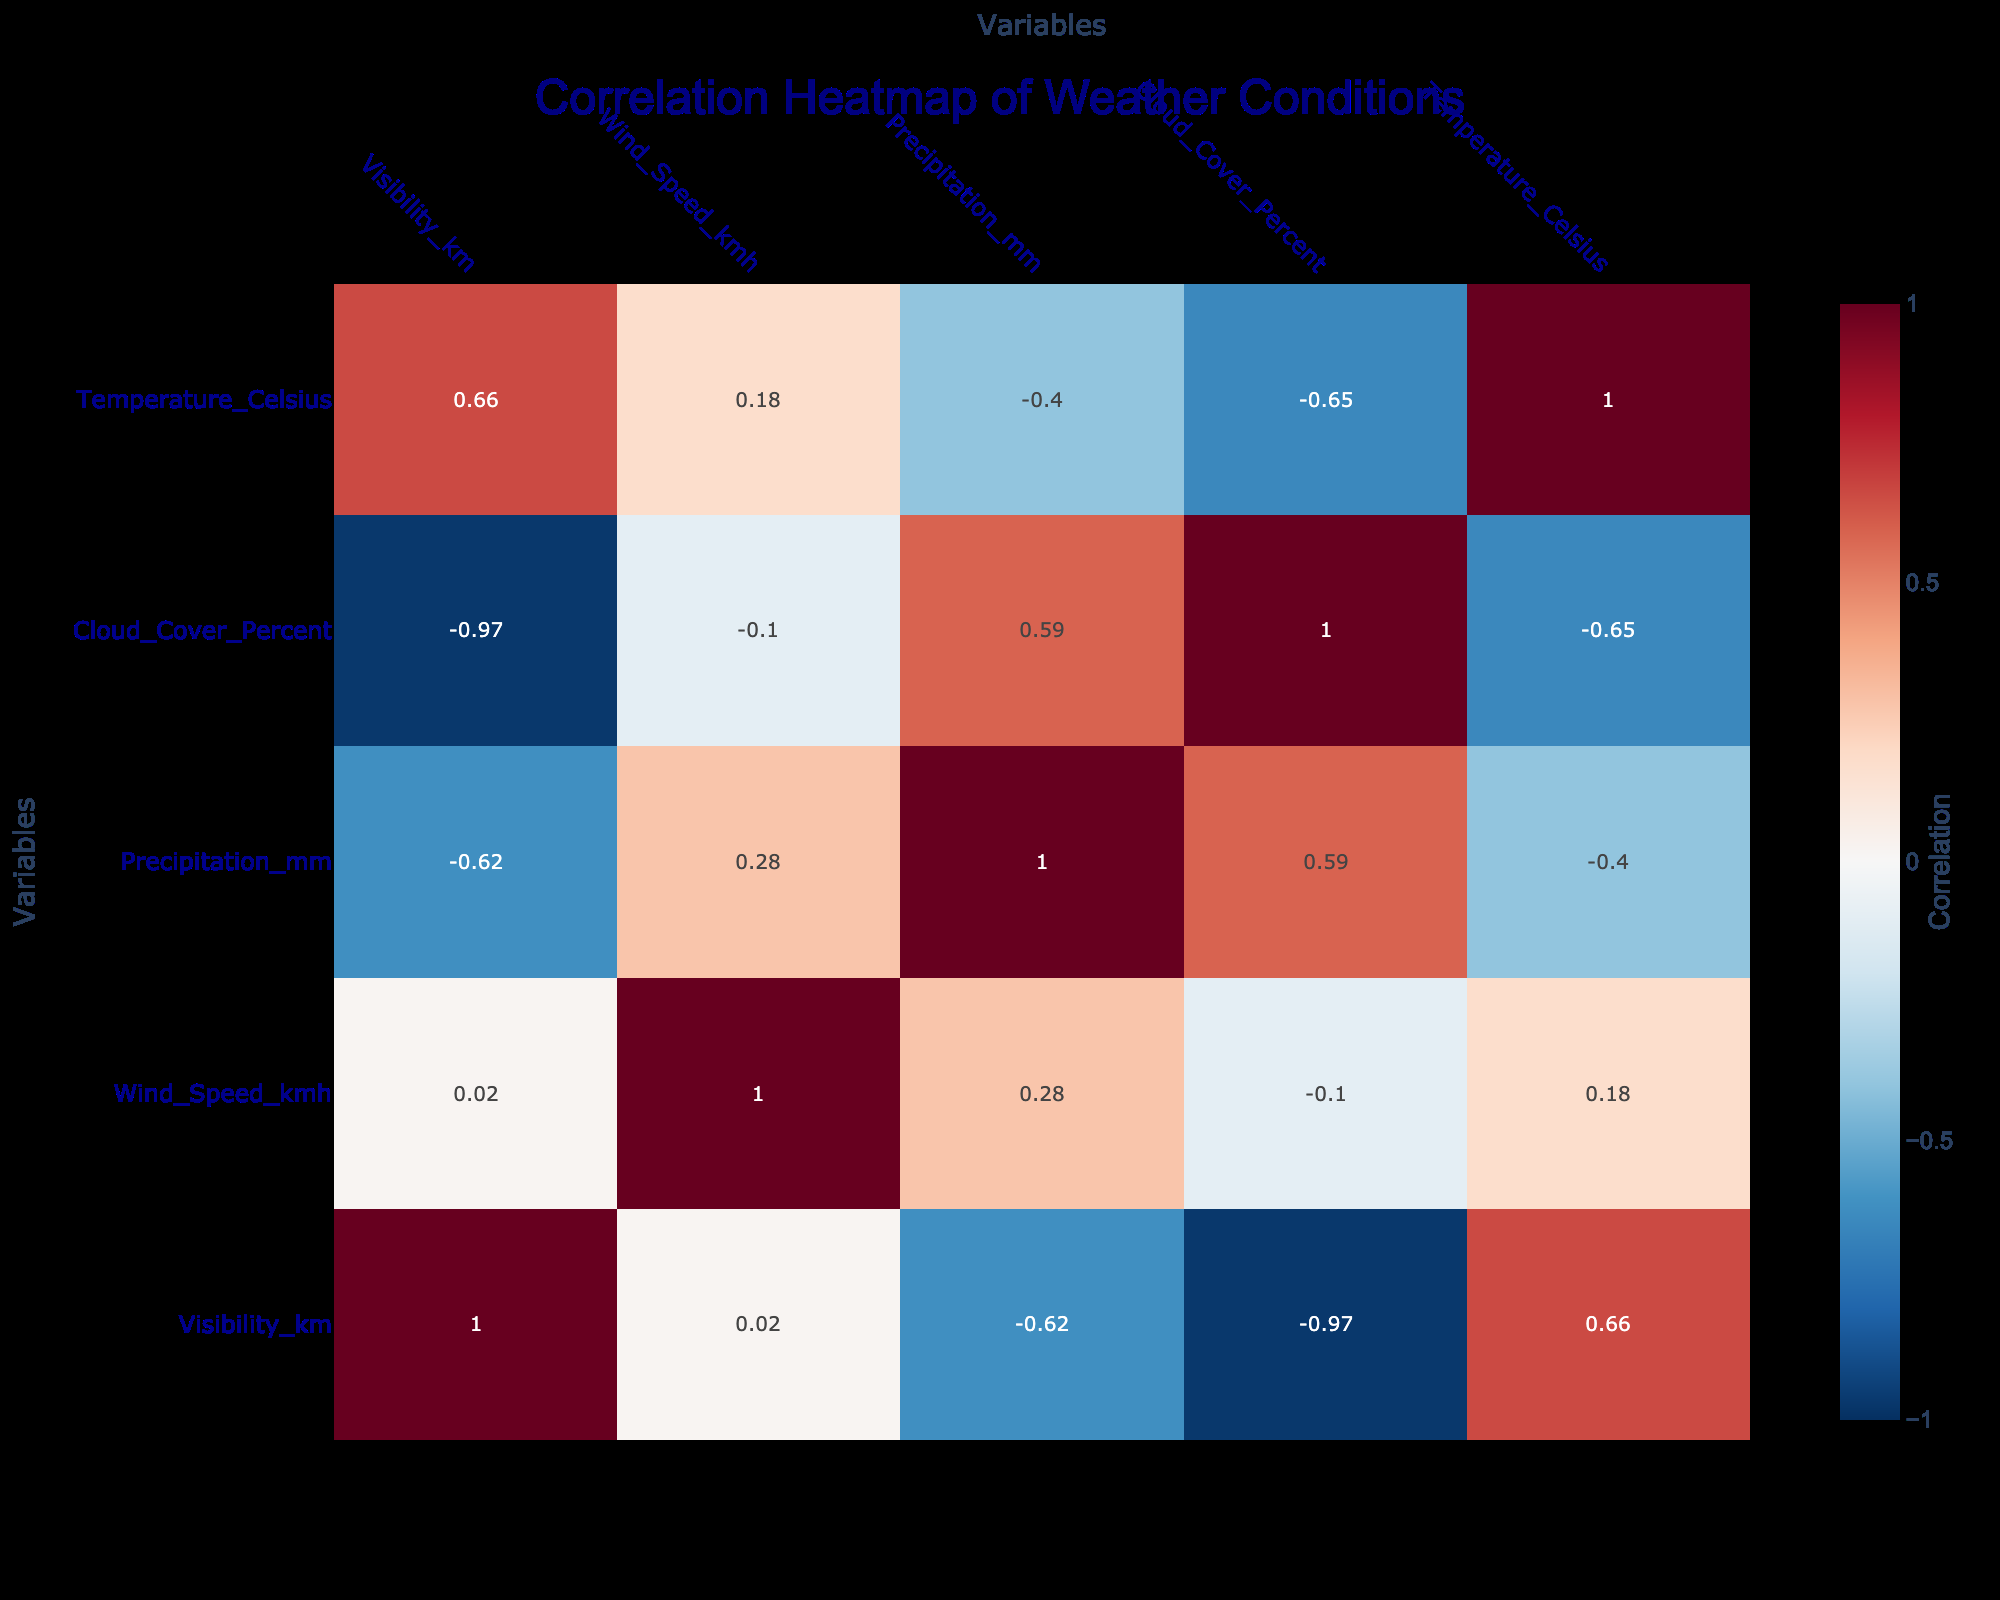What is the correlation between visibility and wind speed? From the correlation table, the value that represents the correlation between visibility (km) and wind speed (km/h) appears in the row for visibility and column for wind speed. This correlation value is -0.16, indicating a slight negative correlation between these two variables.
Answer: -0.16 Which weather condition has the highest correlation with decision to cancel flight? To determine this, we look at the correlation values in the table related to decision-making and find the weather condition that shows the strongest positive or negative correlation with the "Cancel Flight" decision. Fog and Snow are shown to correlate most negatively with "Cancel Flight," with values of -0.94 for Fog and -0.80 for Snow. Thus, Fog has the highest correlation.
Answer: Fog Is there a strong correlation between precipitation and the decision made? Examining the table, the correlation value between precipitation (mm) and decision is -0.76, which indicates a fairly strong negative correlation. This suggests that as precipitation increases, the likelihood of certain decisions, like delaying or canceling flights, also increases.
Answer: Yes What is the average correlation of weather conditions with pilot decisions? To calculate this average, we sum the correlation values for all weather conditions listed and divide by the number of these values. The sum is -0.16 + -0.94 + -0.76 + -0.80 + -0.50 + 0 + -0.34 + 0.15 = -3.55, with 8 values total, giving an average of -3.55 / 8 = -0.44.
Answer: -0.44 Does increased cloud cover correlate positively or negatively with normal flight decisions? Looking at the correlation values, the relationship between cloud cover percent and normal decisions is negative, with a value of -0.72. This indicates that as cloud cover increases, the decision for normal operations decreases significantly.
Answer: Negatively 